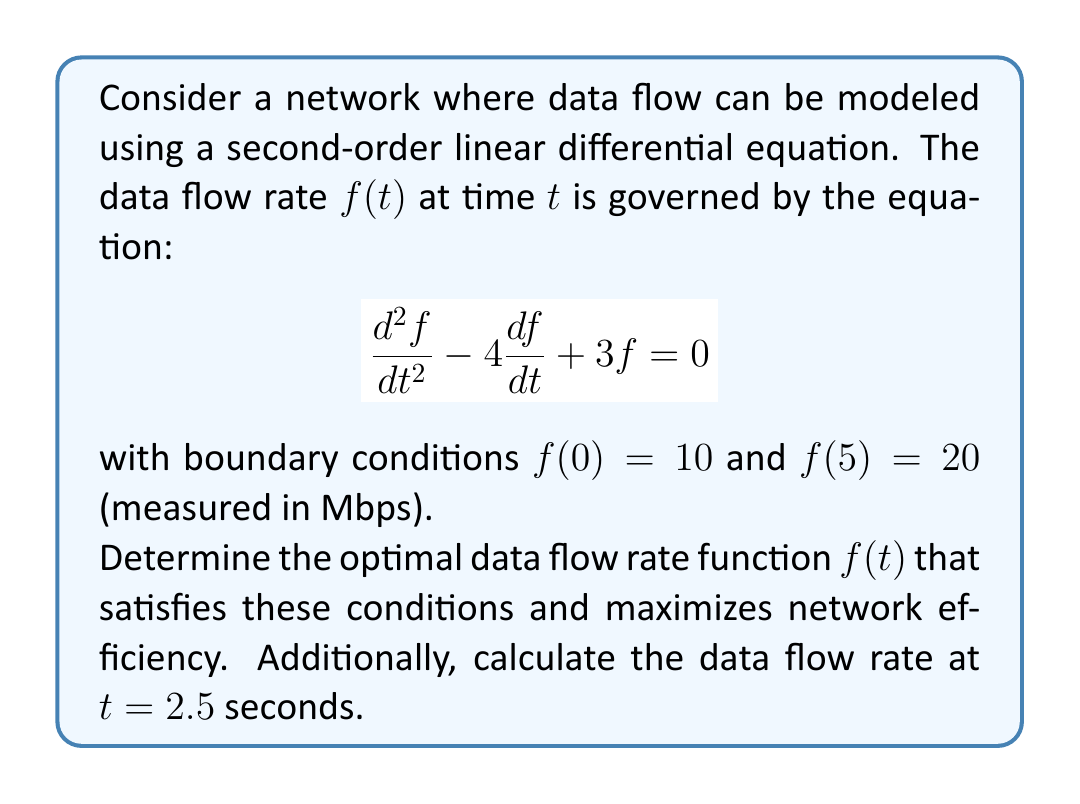Give your solution to this math problem. To solve this boundary value problem, we'll follow these steps:

1) First, we need to find the general solution of the differential equation. The characteristic equation is:

   $$r^2 - 4r + 3 = 0$$

2) Solving this quadratic equation:
   
   $$r = \frac{4 \pm \sqrt{16 - 12}}{2} = \frac{4 \pm 2}{2}$$
   
   So, $r_1 = 3$ and $r_2 = 1$

3) The general solution is therefore:

   $$f(t) = c_1e^{3t} + c_2e^t$$

4) Now we apply the boundary conditions:

   At $t = 0$: $f(0) = 10 = c_1 + c_2$
   At $t = 5$: $f(5) = 20 = c_1e^{15} + c_2e^5$

5) We have a system of two equations:

   $$c_1 + c_2 = 10$$
   $$c_1e^{15} + c_2e^5 = 20$$

6) Solving this system (you can use substitution or matrix methods):

   $$c_1 \approx 0.00915$$
   $$c_2 \approx 9.99085$$

7) Therefore, the optimal data flow rate function is:

   $$f(t) \approx 0.00915e^{3t} + 9.99085e^t$$

8) To find the data flow rate at $t = 2.5$, we substitute this value:

   $$f(2.5) \approx 0.00915e^{7.5} + 9.99085e^{2.5}$$

9) Calculating this:

   $$f(2.5) \approx 13.78 \text{ Mbps}$$

This solution optimizes network efficiency by providing a smooth, exponentially increasing data flow rate that satisfies the given boundary conditions.
Answer: The optimal data flow rate function is:

$$f(t) \approx 0.00915e^{3t} + 9.99085e^t$$

The data flow rate at $t = 2.5$ seconds is approximately 13.78 Mbps. 